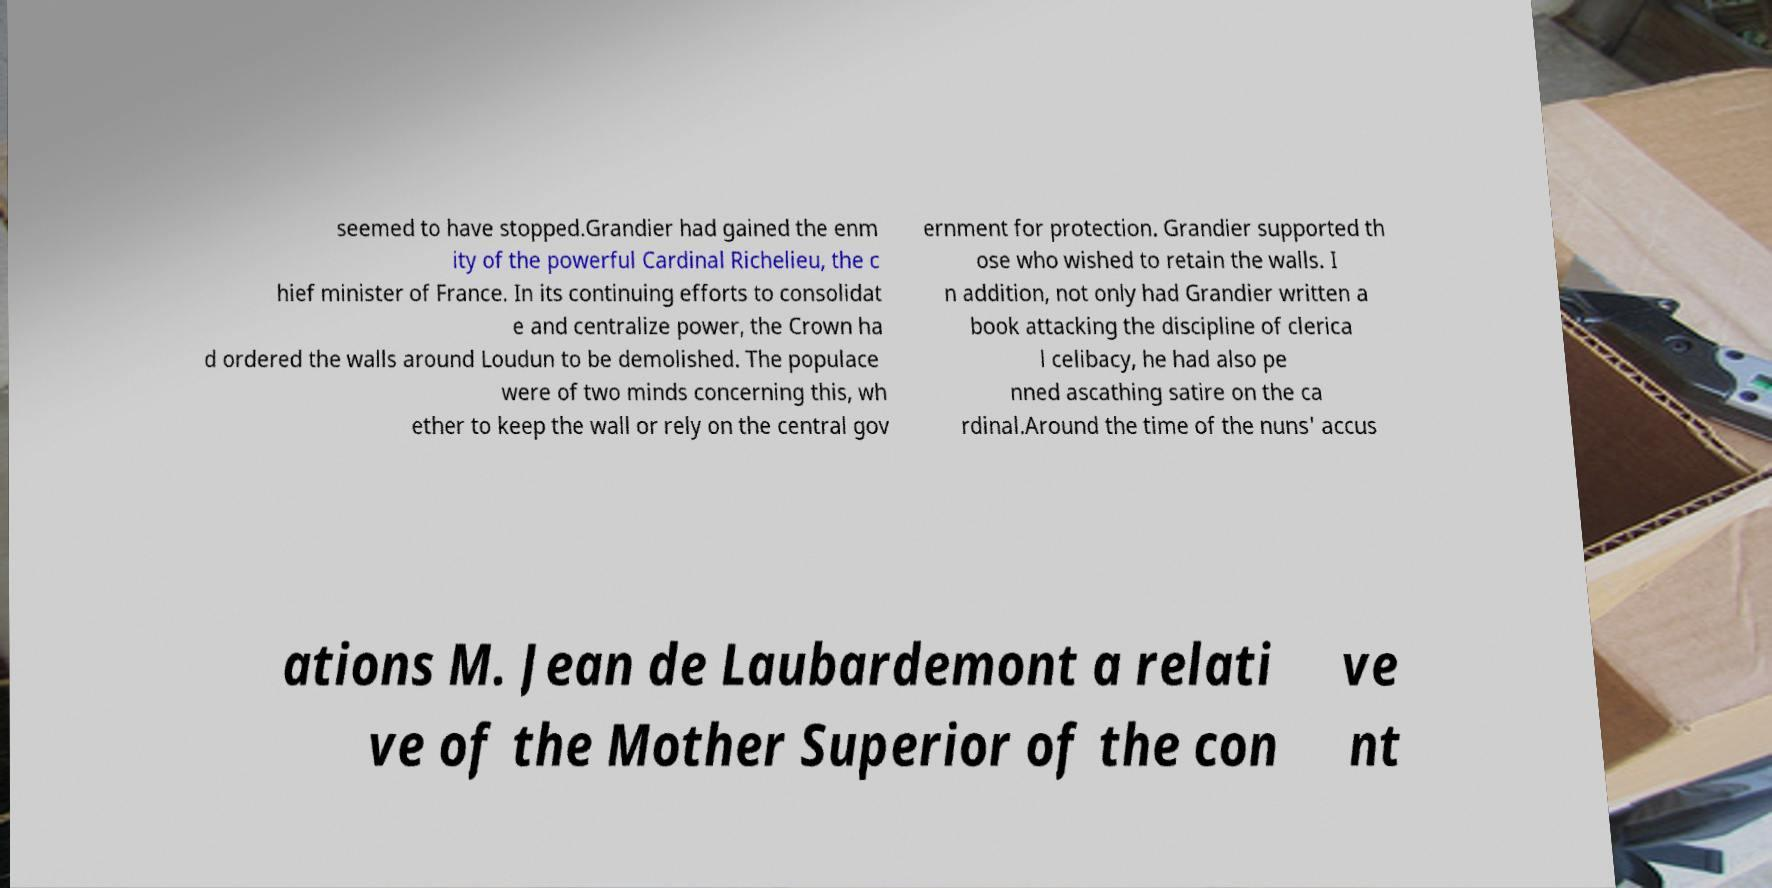Could you assist in decoding the text presented in this image and type it out clearly? seemed to have stopped.Grandier had gained the enm ity of the powerful Cardinal Richelieu, the c hief minister of France. In its continuing efforts to consolidat e and centralize power, the Crown ha d ordered the walls around Loudun to be demolished. The populace were of two minds concerning this, wh ether to keep the wall or rely on the central gov ernment for protection. Grandier supported th ose who wished to retain the walls. I n addition, not only had Grandier written a book attacking the discipline of clerica l celibacy, he had also pe nned ascathing satire on the ca rdinal.Around the time of the nuns' accus ations M. Jean de Laubardemont a relati ve of the Mother Superior of the con ve nt 